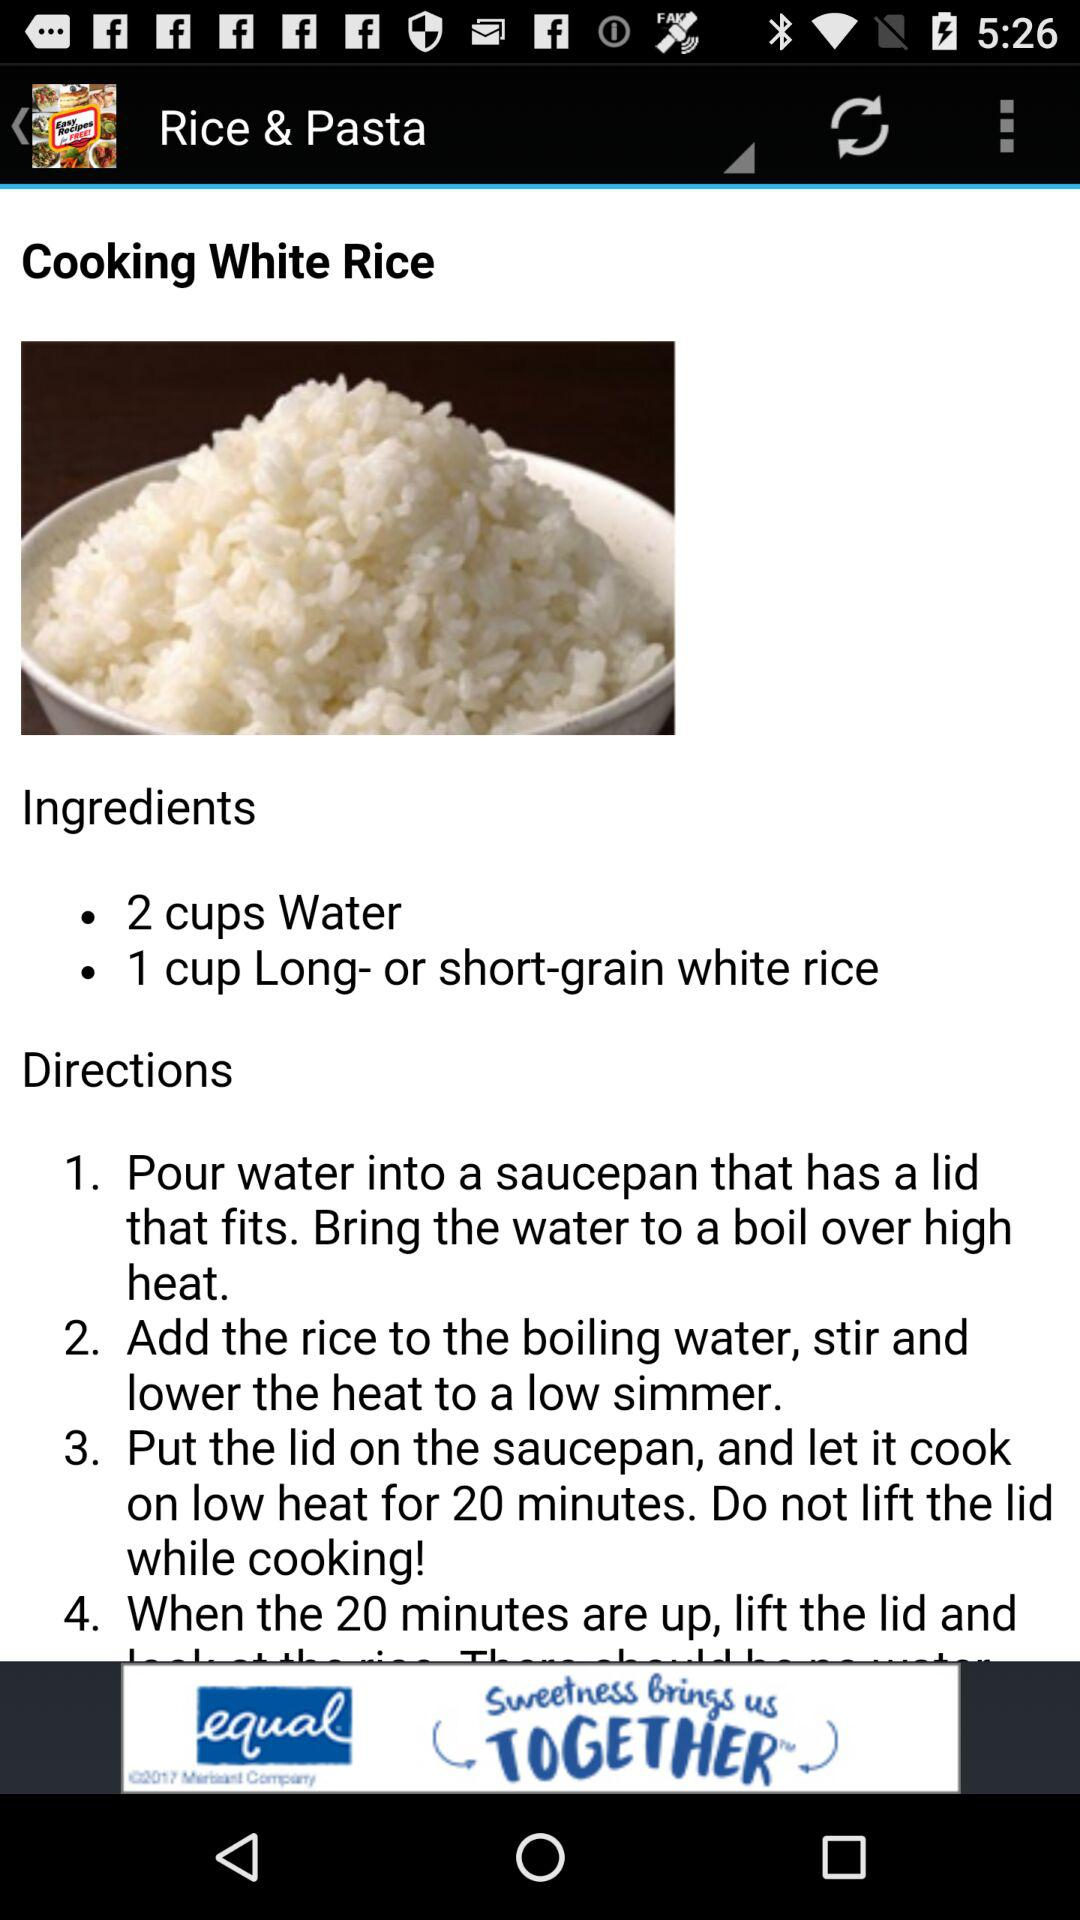What is the name of the recipe? The name of the recipe is "Rice & Pasta". 